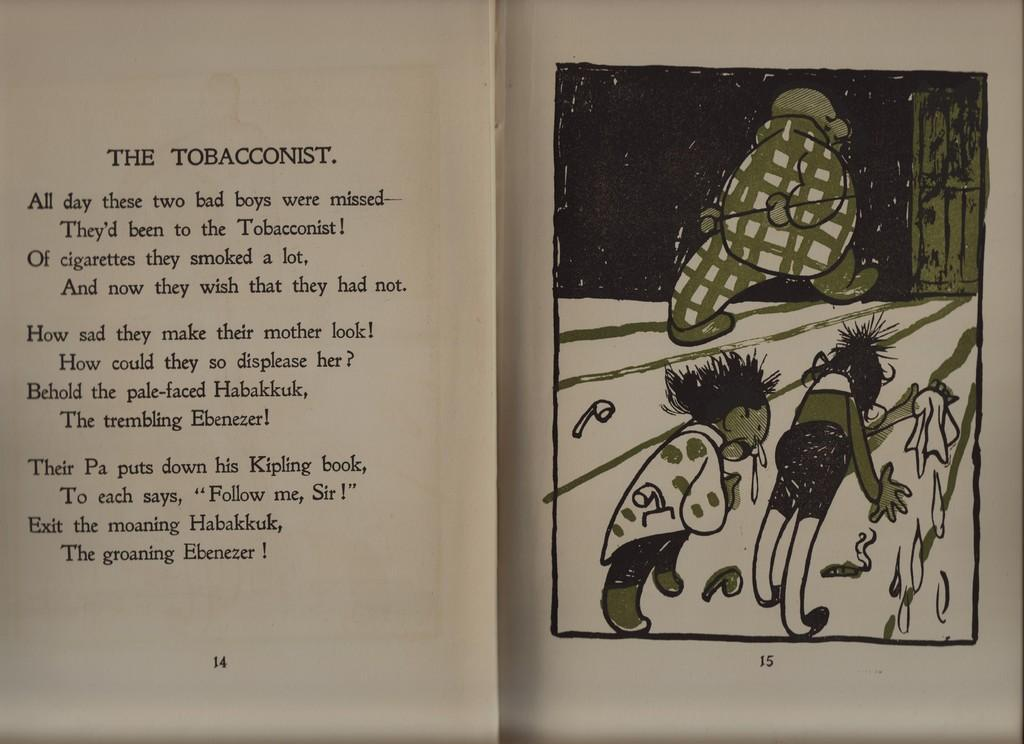<image>
Relay a brief, clear account of the picture shown. A poem in a book titled "The Tobacconist" with an illustration on the other page. 